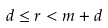Convert formula to latex. <formula><loc_0><loc_0><loc_500><loc_500>d \leq r < m + d</formula> 